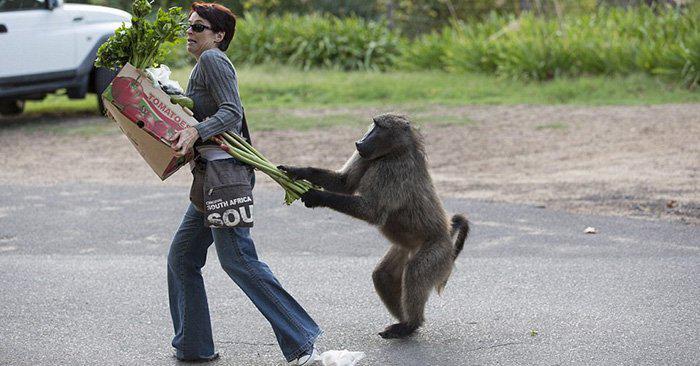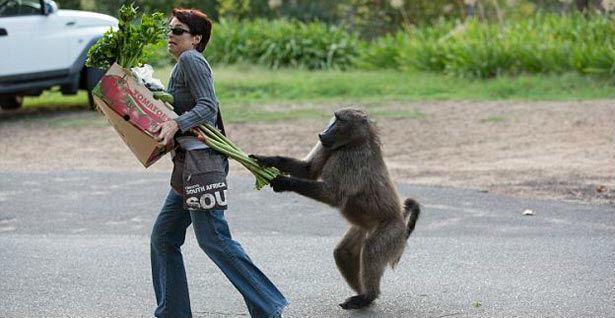The first image is the image on the left, the second image is the image on the right. For the images displayed, is the sentence "There is one statue that features one brown monkey and another statue that depicts three black monkeys in various poses." factually correct? Answer yes or no. No. 